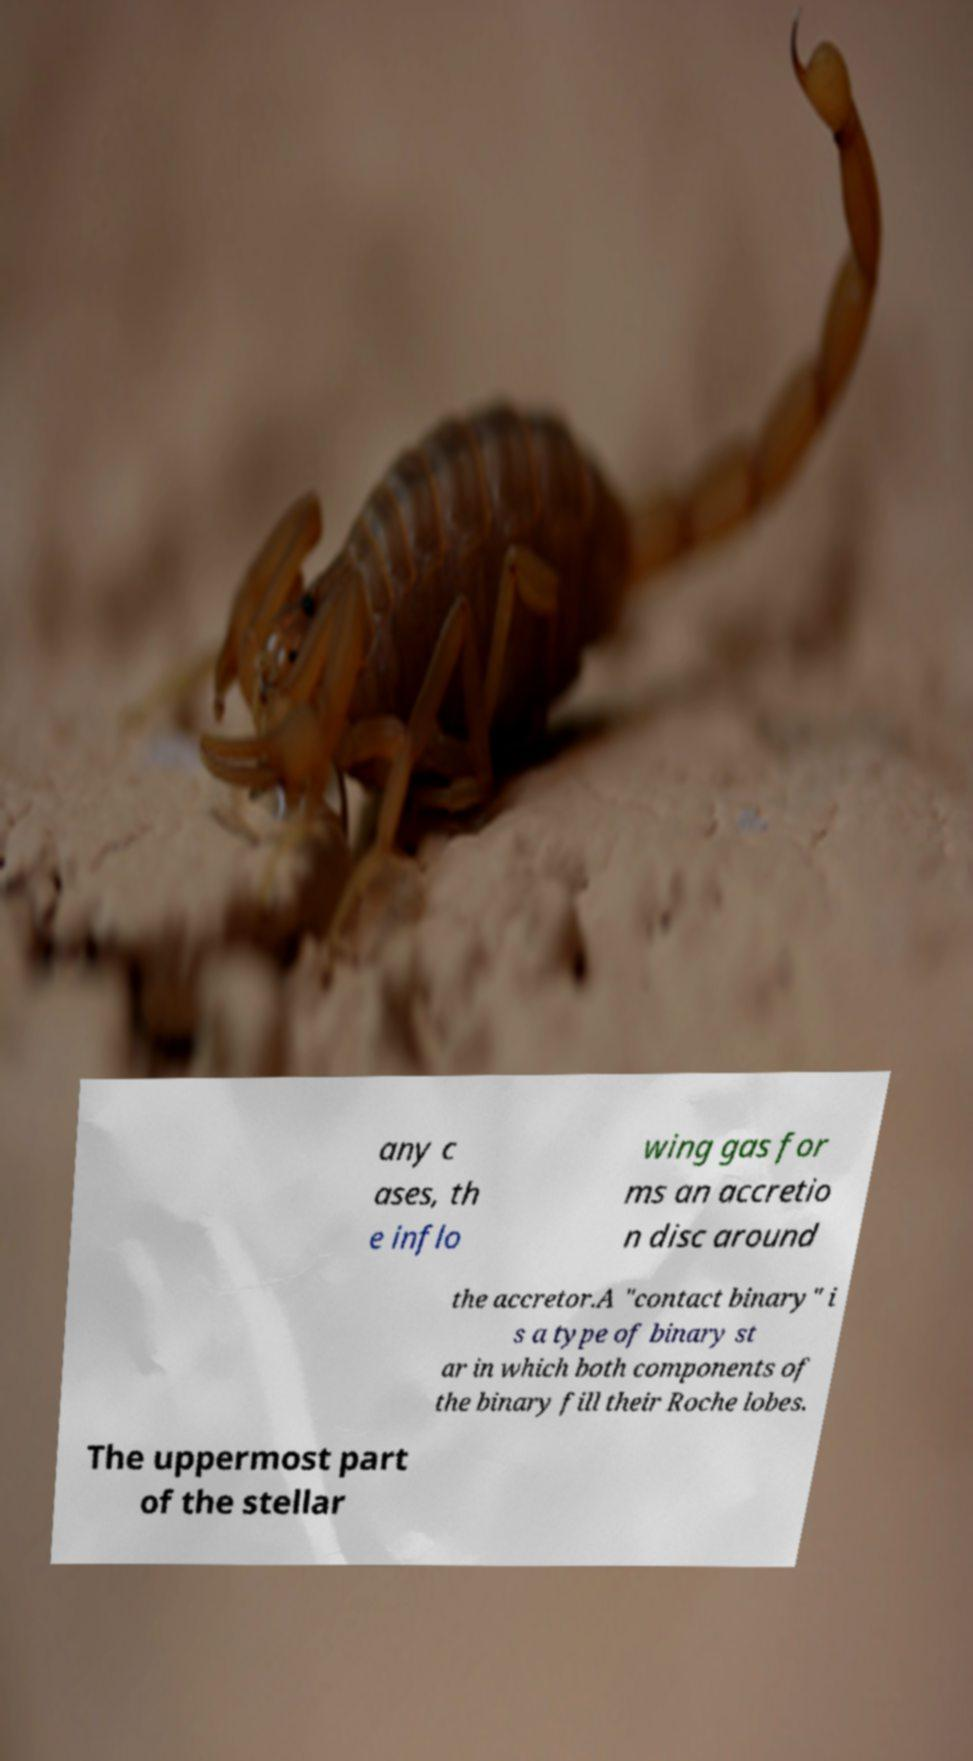Could you assist in decoding the text presented in this image and type it out clearly? any c ases, th e inflo wing gas for ms an accretio n disc around the accretor.A "contact binary" i s a type of binary st ar in which both components of the binary fill their Roche lobes. The uppermost part of the stellar 